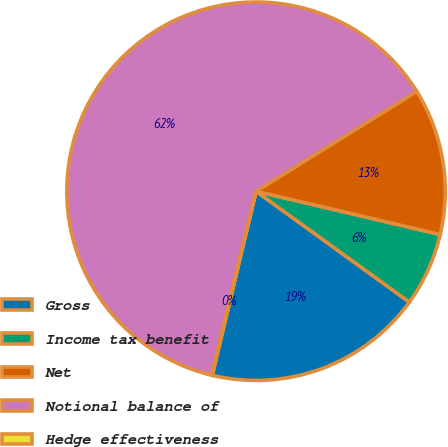<chart> <loc_0><loc_0><loc_500><loc_500><pie_chart><fcel>Gross<fcel>Income tax benefit<fcel>Net<fcel>Notional balance of<fcel>Hedge effectiveness<nl><fcel>18.75%<fcel>6.29%<fcel>12.52%<fcel>62.38%<fcel>0.06%<nl></chart> 